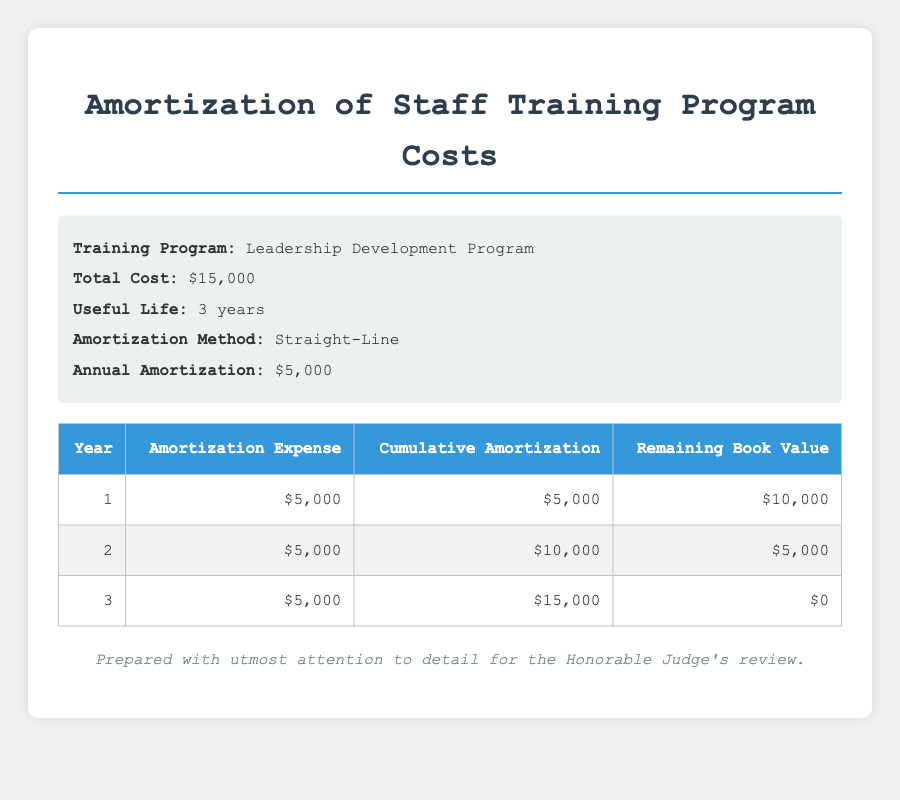What is the annual amortization for the Leadership Development Program? The table provides a specific entry for the annual amortization, which is listed in the information section as $5,000.
Answer: 5000 How much is the cumulative amortization at the end of Year 2? By referring to the table, the cumulative amortization at the end of Year 2 is shown as $10,000.
Answer: 10000 What is the remaining book value after Year 1? The table indicates that the remaining book value after Year 1 is $10,000, as stated in the corresponding row.
Answer: 10000 Is the total cost of the training program amortized by the end of Year 3? The total cost of the training program is $15,000, and the cumulative amortization by the end of Year 3 is also $15,000, confirming that it is fully amortized.
Answer: Yes What is the total amortization expense over the three years? The annual amortization is $5,000 for each year. Adding these three amounts gives $5,000 + $5,000 + $5,000 = $15,000, which is the total amortization expense.
Answer: 15000 What is the difference between the remaining book value at the end of Year 1 and Year 2? The remaining book value for Year 1 is $10,000, and for Year 2 it is $5,000. The difference is calculated as $10,000 - $5,000 = $5,000.
Answer: 5000 Is the amortization method used a straight-line method? The information section explicitly states that the amortization method is "Straight-Line," confirming that it is true.
Answer: Yes What is the average annual amortization expense over the three years? Since the annual amortization is constant at $5,000 for each of the three years, the average remains $5,000, meaning the total amortization is $15,000 divided by 3 equals $5,000.
Answer: 5000 What is the cumulative amortization at the end of Year 1 compared to Year 3? The cumulative amortization at Year 1 is $5,000 and at Year 3 is $15,000. Comparing these gives $15,000 - $5,000 = $10,000.
Answer: 10000 